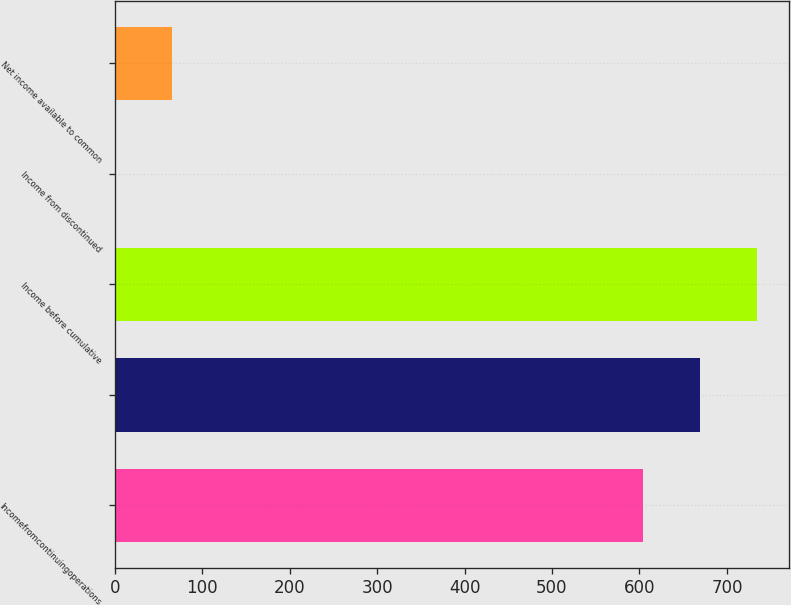<chart> <loc_0><loc_0><loc_500><loc_500><bar_chart><fcel>Incomefromcontinuingoperations<fcel>Unnamed: 1<fcel>Income before cumulative<fcel>Income from discontinued<fcel>Net income available to common<nl><fcel>604<fcel>668.99<fcel>733.98<fcel>0.06<fcel>65.05<nl></chart> 